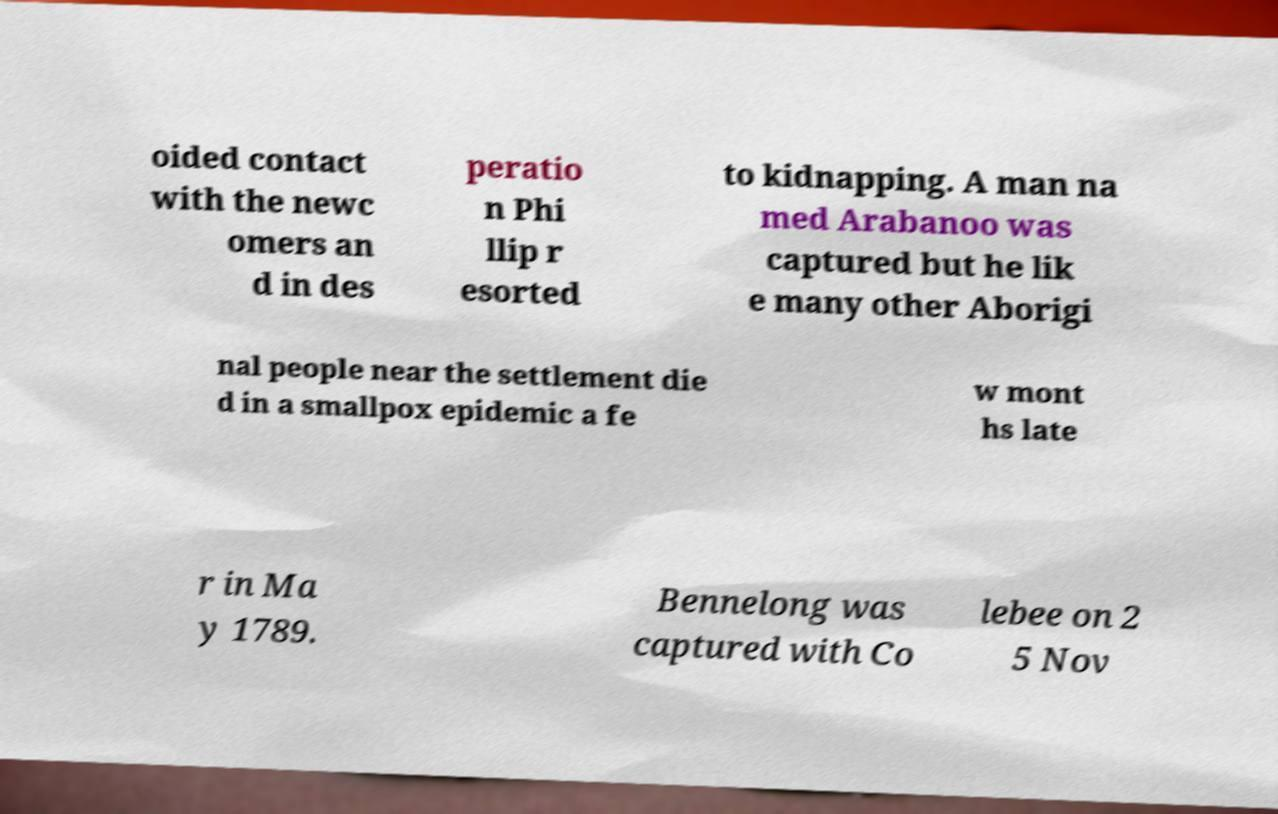Could you assist in decoding the text presented in this image and type it out clearly? oided contact with the newc omers an d in des peratio n Phi llip r esorted to kidnapping. A man na med Arabanoo was captured but he lik e many other Aborigi nal people near the settlement die d in a smallpox epidemic a fe w mont hs late r in Ma y 1789. Bennelong was captured with Co lebee on 2 5 Nov 